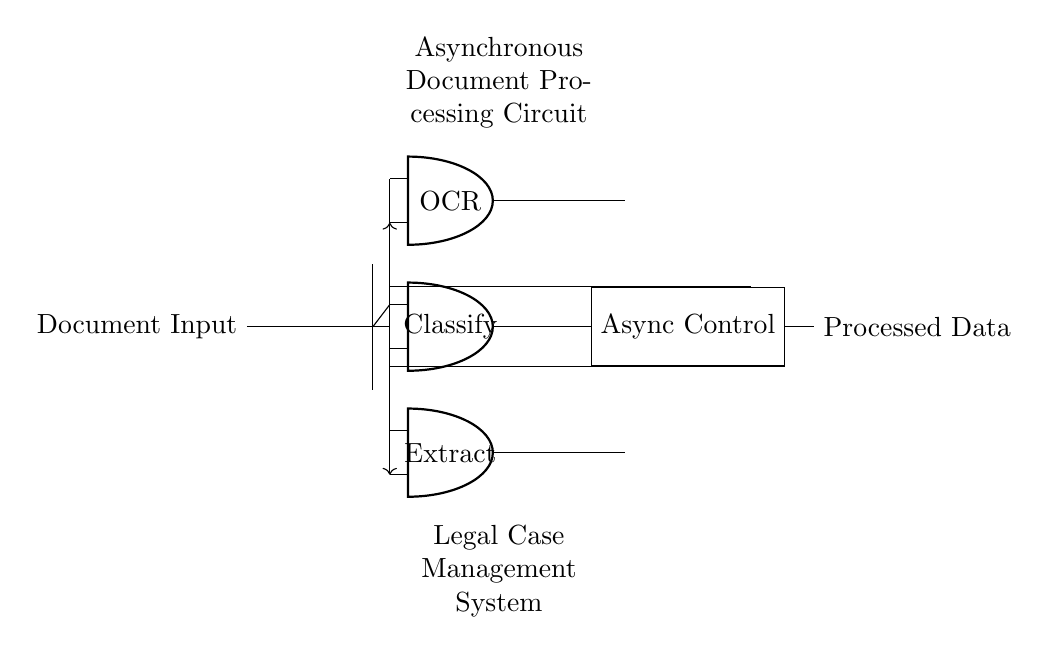What is the main function of the OCR unit? The OCR unit's primary function is to perform optical character recognition, converting scanned documents into machine-encoded text.
Answer: Optical character recognition Which component buffers the document input? The buffer is the component that provides temporary storage and organizes the flow from the document input to the processing units.
Answer: Buffer How many processing units are present in the circuit? There are three processing units: OCR, Classify, and Extract. Counting each unit provides clarity about the layout and complexity of the system.
Answer: Three What type of control does the circuit use for processing? The circuit employs asynchronous control, which manages the operations of processing units without relying on a global clock signal.
Answer: Async Describe the connection method from the document input to the processing units. The document input connects to the processing units via a combination of direct and split connections, providing flexibility in data distribution among the units.
Answer: Split connections What is the role of feedback loops in this circuit? The feedback loops are used to send output signals back to the inputs of OCR and Extract, allowing for dynamic adjustments and improvements in the processing.
Answer: Adjustment and improvement Which part of the circuit generates processed data? The Async Control unit is responsible for generating and outputting the processed data after coordinating the actions of the processing units.
Answer: Async Control 